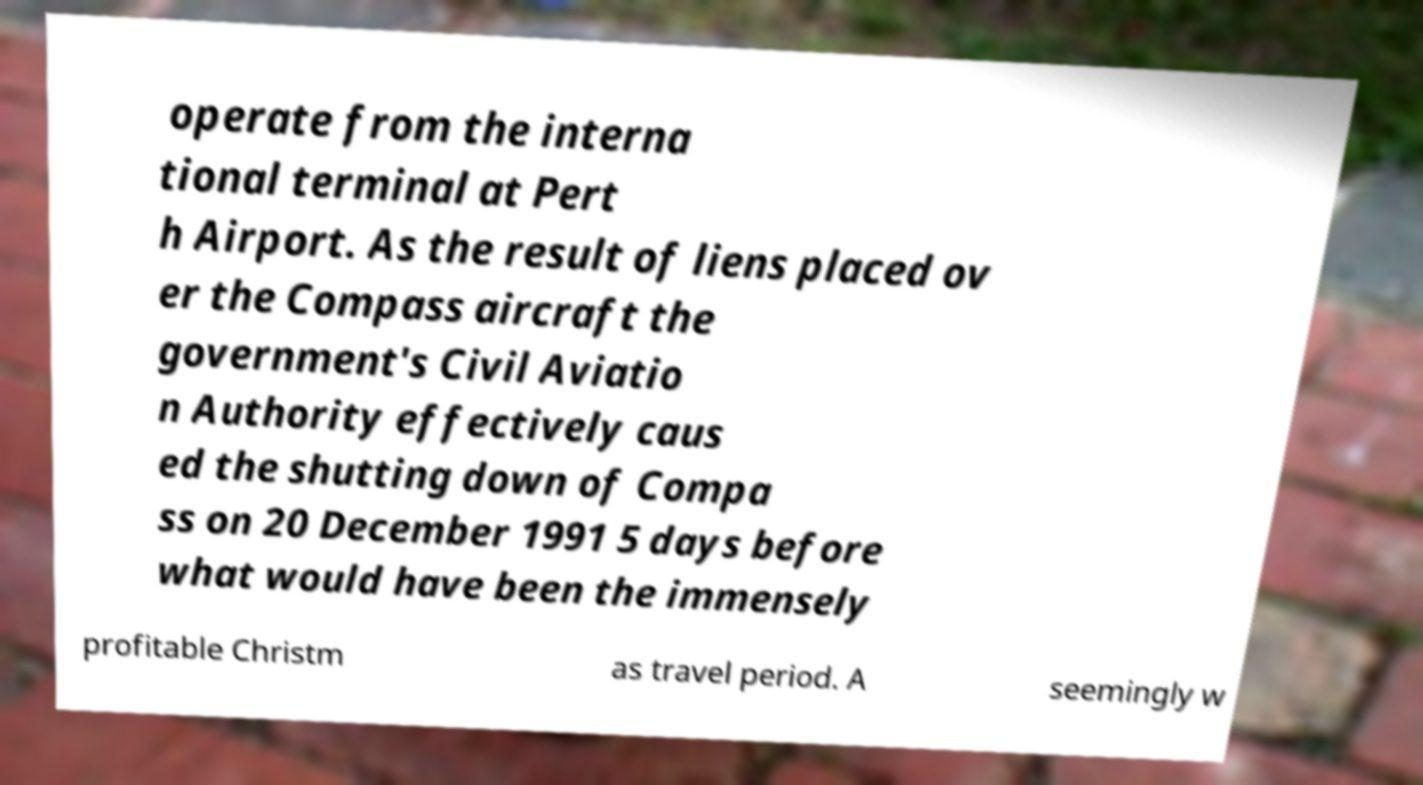Could you extract and type out the text from this image? operate from the interna tional terminal at Pert h Airport. As the result of liens placed ov er the Compass aircraft the government's Civil Aviatio n Authority effectively caus ed the shutting down of Compa ss on 20 December 1991 5 days before what would have been the immensely profitable Christm as travel period. A seemingly w 